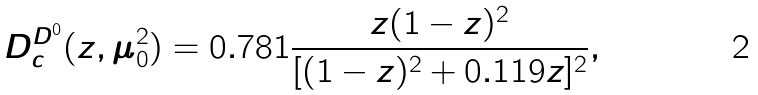<formula> <loc_0><loc_0><loc_500><loc_500>D _ { c } ^ { D ^ { 0 } } ( z , \mu _ { 0 } ^ { 2 } ) = 0 . 7 8 1 \frac { z ( 1 - z ) ^ { 2 } } { [ ( 1 - z ) ^ { 2 } + 0 . 1 1 9 z ] ^ { 2 } } ,</formula> 